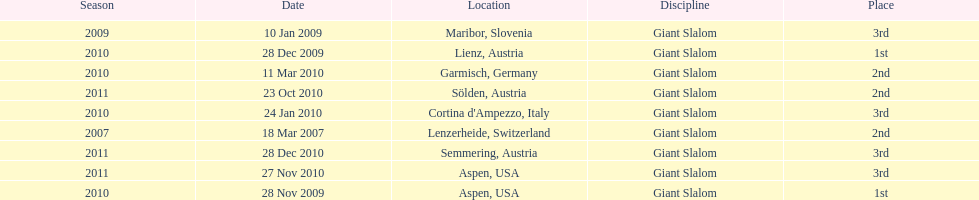Where was her first win? Aspen, USA. 